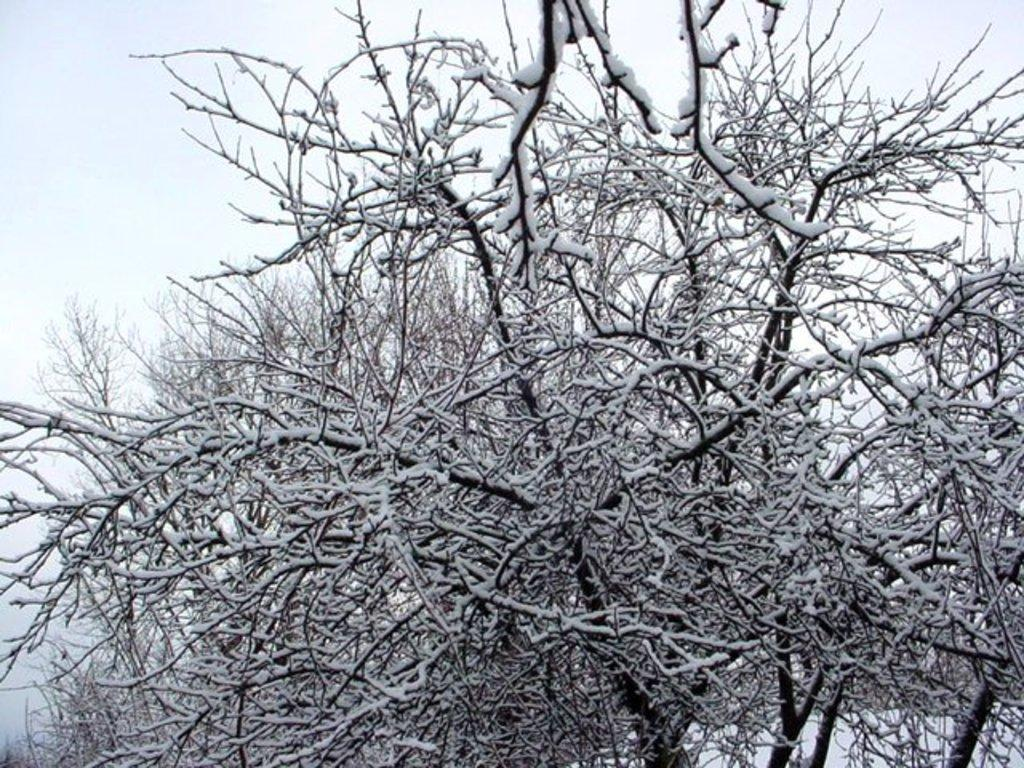What type of vegetation can be seen in the image? There are trees in the image. What is covering the ground in the image? There is snow on the ground in the image. Are the trees also covered in the same substance as the ground? Yes, there is snow on the trees in the image. How would you describe the weather based on the sky in the image? The sky is cloudy in the image. What time is it according to the clocks in the image? There are no clocks present in the image. What season is it based on the presence of snow in the image? The presence of snow suggests that it is winter, not summer. 